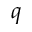<formula> <loc_0><loc_0><loc_500><loc_500>q</formula> 